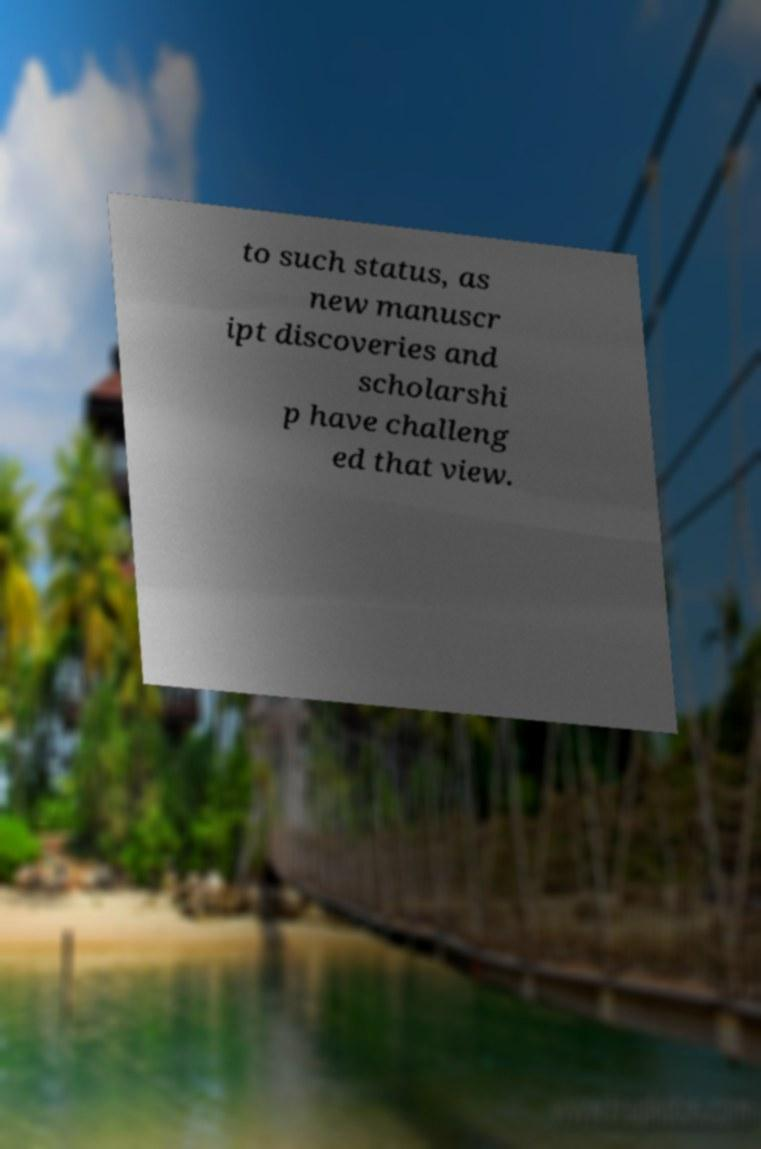Can you accurately transcribe the text from the provided image for me? to such status, as new manuscr ipt discoveries and scholarshi p have challeng ed that view. 